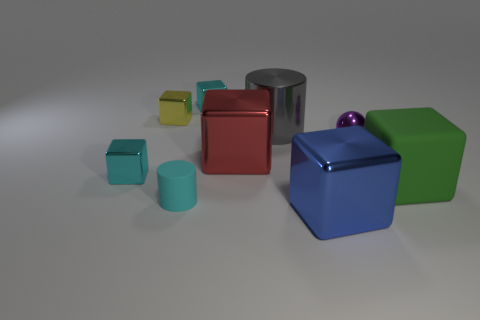Are there any patterns or themes in the arrangement of objects? The arrangement of objects doesn't show a clear pattern, but there is a theme of geometric shapes and varying colors. The objects are placed with a sense of randomness yet balanced in spatial distribution, creating a visually appealing composition that plays with color contrast and form. 